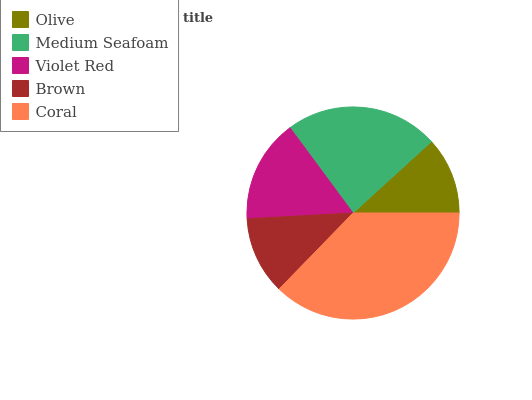Is Olive the minimum?
Answer yes or no. Yes. Is Coral the maximum?
Answer yes or no. Yes. Is Medium Seafoam the minimum?
Answer yes or no. No. Is Medium Seafoam the maximum?
Answer yes or no. No. Is Medium Seafoam greater than Olive?
Answer yes or no. Yes. Is Olive less than Medium Seafoam?
Answer yes or no. Yes. Is Olive greater than Medium Seafoam?
Answer yes or no. No. Is Medium Seafoam less than Olive?
Answer yes or no. No. Is Violet Red the high median?
Answer yes or no. Yes. Is Violet Red the low median?
Answer yes or no. Yes. Is Olive the high median?
Answer yes or no. No. Is Brown the low median?
Answer yes or no. No. 